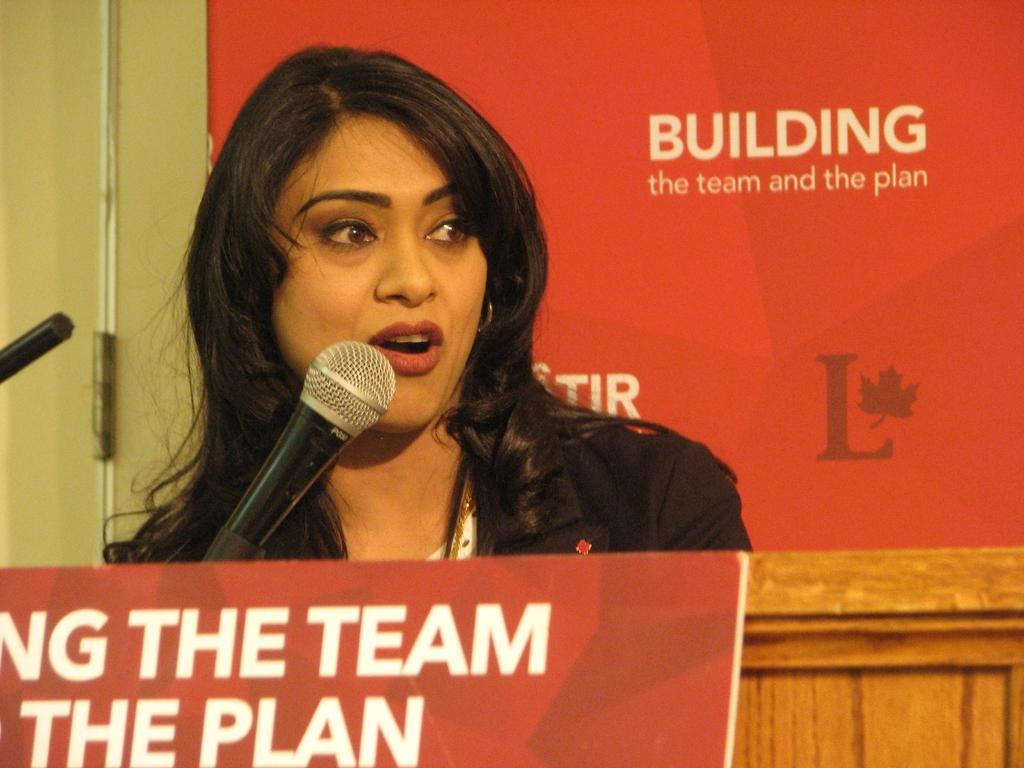Who is present in the image? There is a woman in the image. What is the woman doing in the image? The woman is standing and speaking with the help of a microphone. What can be seen on the boards in the image? There are boards with text in the image. Are there any ants crawling on the woman's feet in the image? There is no indication of ants or any insects in the image. 